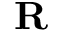Convert formula to latex. <formula><loc_0><loc_0><loc_500><loc_500>R</formula> 